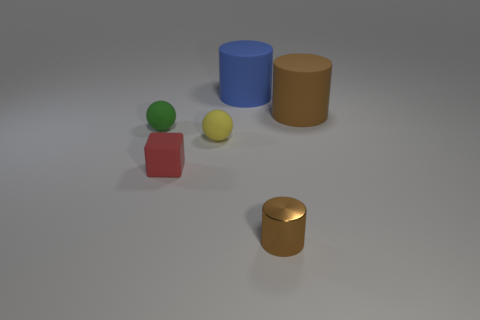Subtract all blue rubber cylinders. How many cylinders are left? 2 Add 2 brown metallic things. How many objects exist? 8 Subtract all yellow balls. How many balls are left? 1 Subtract all balls. How many objects are left? 4 Subtract all large green matte blocks. Subtract all small green balls. How many objects are left? 5 Add 2 small cylinders. How many small cylinders are left? 3 Add 2 large brown matte things. How many large brown matte things exist? 3 Subtract 1 green balls. How many objects are left? 5 Subtract 1 blocks. How many blocks are left? 0 Subtract all yellow spheres. Subtract all blue cylinders. How many spheres are left? 1 